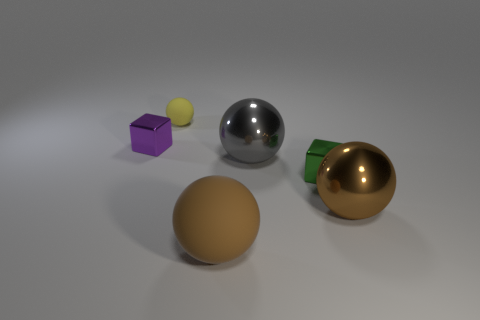Is this image likely to be used for commercial purposes? This image could be used for commercial purposes such as a stock image for demonstrating rendering techniques, showcasing materials in product visualizations, or as part of an advertisement for objects similar to those depicted. The clean and straightforward presentation makes it versatile for various applications. 